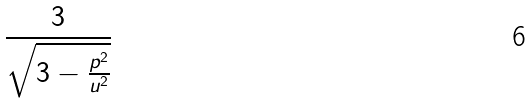<formula> <loc_0><loc_0><loc_500><loc_500>\frac { 3 } { \sqrt { 3 - \frac { p ^ { 2 } } { u ^ { 2 } } } }</formula> 